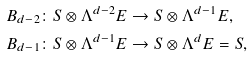<formula> <loc_0><loc_0><loc_500><loc_500>B _ { d - 2 } & \colon S \otimes \Lambda ^ { d - 2 } E \to S \otimes \Lambda ^ { d - 1 } E , \\ B _ { d - 1 } & \colon S \otimes \Lambda ^ { d - 1 } E \to S \otimes \Lambda ^ { d } E = S ,</formula> 